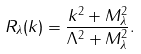<formula> <loc_0><loc_0><loc_500><loc_500>R _ { \lambda } ( k ) = \frac { k ^ { 2 } + M ^ { 2 } _ { \lambda } } { \Lambda ^ { 2 } + M ^ { 2 } _ { \lambda } } .</formula> 